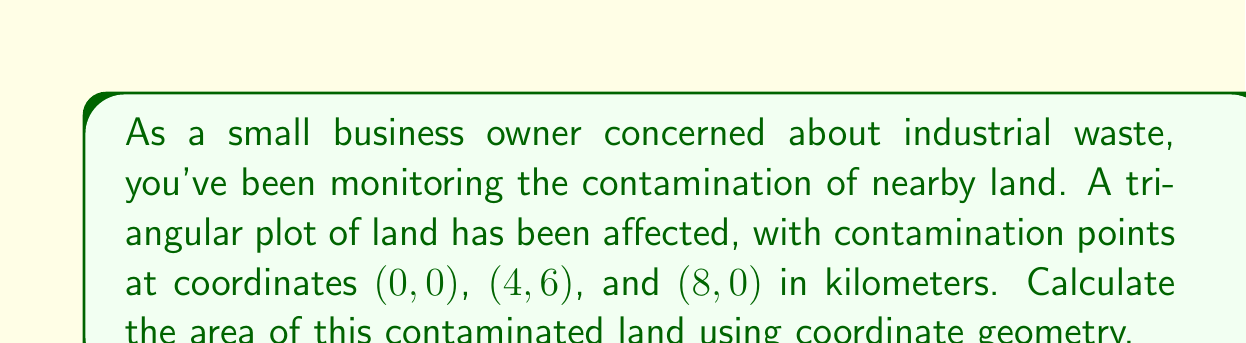What is the answer to this math problem? To calculate the area of the triangular contaminated land, we can use the formula for the area of a triangle given the coordinates of its vertices:

$$A = \frac{1}{2}|x_1(y_2 - y_3) + x_2(y_3 - y_1) + x_3(y_1 - y_2)|$$

Where $(x_1, y_1)$, $(x_2, y_2)$, and $(x_3, y_3)$ are the coordinates of the three vertices.

Let's substitute the given coordinates:
$(x_1, y_1) = (0, 0)$
$(x_2, y_2) = (4, 6)$
$(x_3, y_3) = (8, 0)$

Now, let's plug these into the formula:

$$A = \frac{1}{2}|0(6 - 0) + 4(0 - 0) + 8(0 - 6)|$$

Simplifying:
$$A = \frac{1}{2}|0 + 0 + 8(-6)|$$
$$A = \frac{1}{2}|-48|$$
$$A = \frac{1}{2}(48)$$
$$A = 24$$

The area is 24 square kilometers.

[asy]
unitsize(1cm);
draw((0,0)--(4,6)--(8,0)--cycle);
dot((0,0));
dot((4,6));
dot((8,0));
label("(0,0)", (0,0), SW);
label("(4,6)", (4,6), N);
label("(8,0)", (8,0), SE);
[/asy]
Answer: 24 km² 